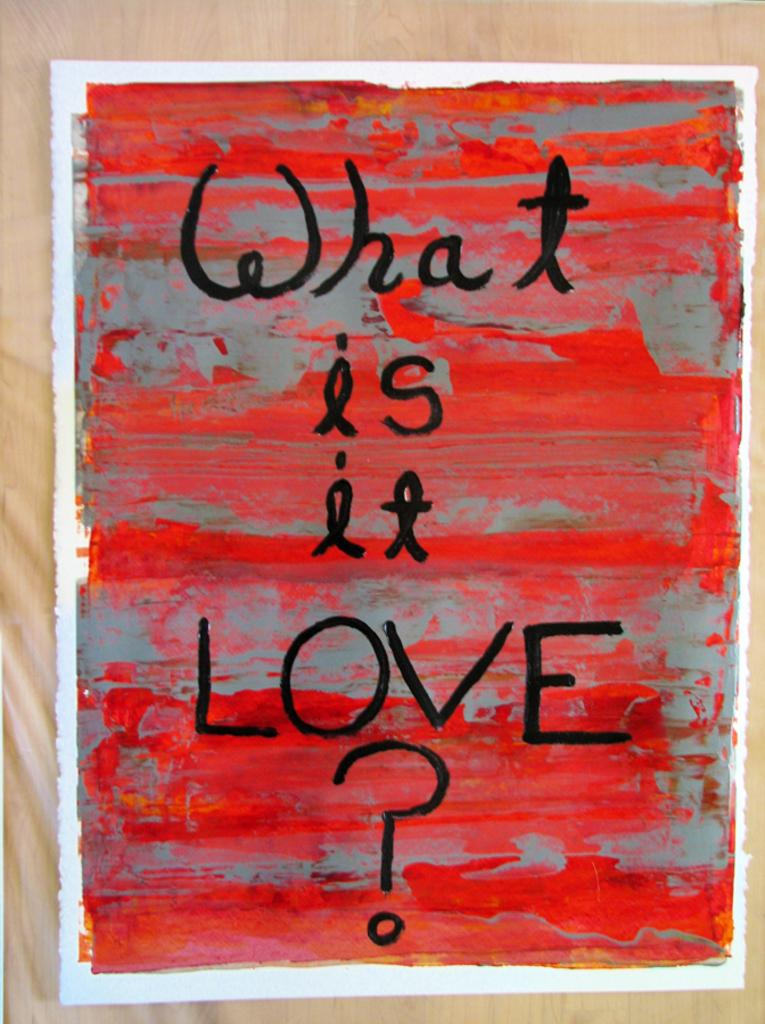Provide a one-sentence caption for the provided image. A poster in red and gray that is titled What Is It Love. 